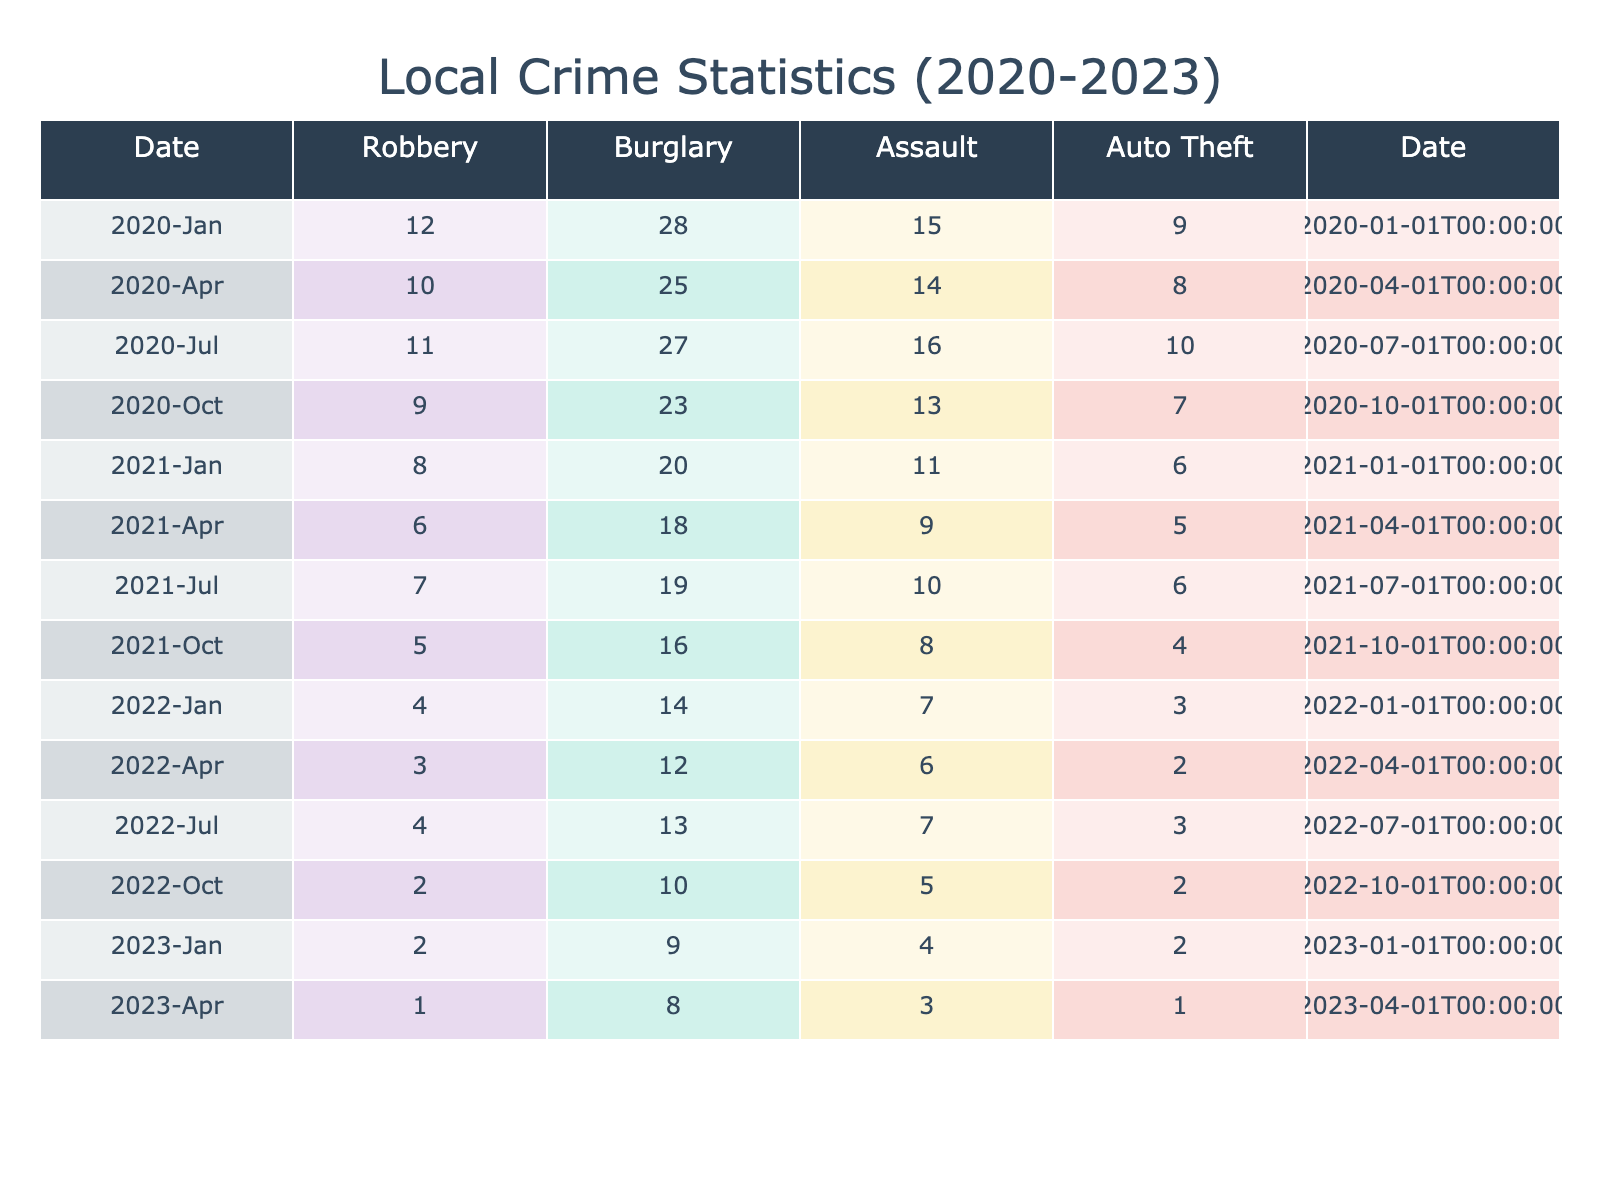What was the total number of robberies in 2020? To find this, I need to add the number of robberies for each month in 2020. The values are 12 (January) + 10 (April) + 11 (July) + 9 (October) = 42.
Answer: 42 What was the highest number of burglaries recorded in a single month from 2021 to 2023? I will look for the maximum value of burglaries in the months listed between 2021 and 2023. The values are 20 (January 2021), 18 (April 2021), 19 (July 2021), 16 (October 2021), 14 (January 2022), 12 (April 2022), 13 (July 2022), 10 (October 2022), 9 (January 2023), 8 (April 2023). The highest value is 20 in January 2021.
Answer: 20 Was there a decrease in assault cases in January from 2020 to 2023? I will compare the number of assault cases in January for each year. In 2020, there were 15 cases, 2021 had 11 cases, 2022 had 7 cases, and 2023 had 4 cases. Since all values decreased from 15 to 4, the answer is yes.
Answer: Yes What was the percentage decrease in auto theft from October 2020 to April 2023? First, identify the values for auto theft: October 2020 had 9 cases and April 2023 had 1 case. To find the percent decrease, I calculate ((9 - 1) / 9) * 100 = 88.89%.
Answer: 88.89% How many months had fewer than 5 robberies from 2021 to 2023? I will count the months that had fewer than 5 robberies. The values for robberies in these months are 5 (October 2021), 4 (January 2022), 3 (April 2022), 4 (July 2022), 2 (October 2022), 2 (January 2023), and 1 (April 2023). That is a total of 5 months.
Answer: 5 What is the average number of burglaries in 2022? I will sum the monthly burglaries in 2022 and then divide by the number of months. The values are 14 (January) + 12 (April) + 13 (July) + 10 (October) = 49. There are 4 months, so the average is 49 / 4 = 12.25.
Answer: 12.25 Was there an increase in robbery cases from April 2021 to July 2021? I will compare the robbery cases of both months: April 2021 had 6 cases and July 2021 had 7 cases. Since 7 is greater than 6, there was an increase.
Answer: Yes What was the difference in total assaults between the years 2020 and 2022? First, I need to sum the assaults for each year. For 2020, the total is 15 (January) + 14 (April) + 16 (July) + 13 (October) = 58. For 2022, the total is 7 (January) + 6 (April) + 7 (July) + 5 (October) = 25. The difference is 58 - 25 = 33.
Answer: 33 What is the lowest monthly total of car thefts recorded in the provided data? I will search the auto theft values for the lowest entry among the months. The values range from 9, 8, 10, 7, down to 1 at April 2023. Thus, the lowest total is 1.
Answer: 1 How many months had robberies of 7 or more from January 2020 to April 2023? I will go through the data for robberies and count the months where the robbery count was 7 or higher. The qualifying months are January 2020, April 2020, July 2020, January 2021, April 2021, July 2021, January 2022, and July 2022, totaling 8 months.
Answer: 8 